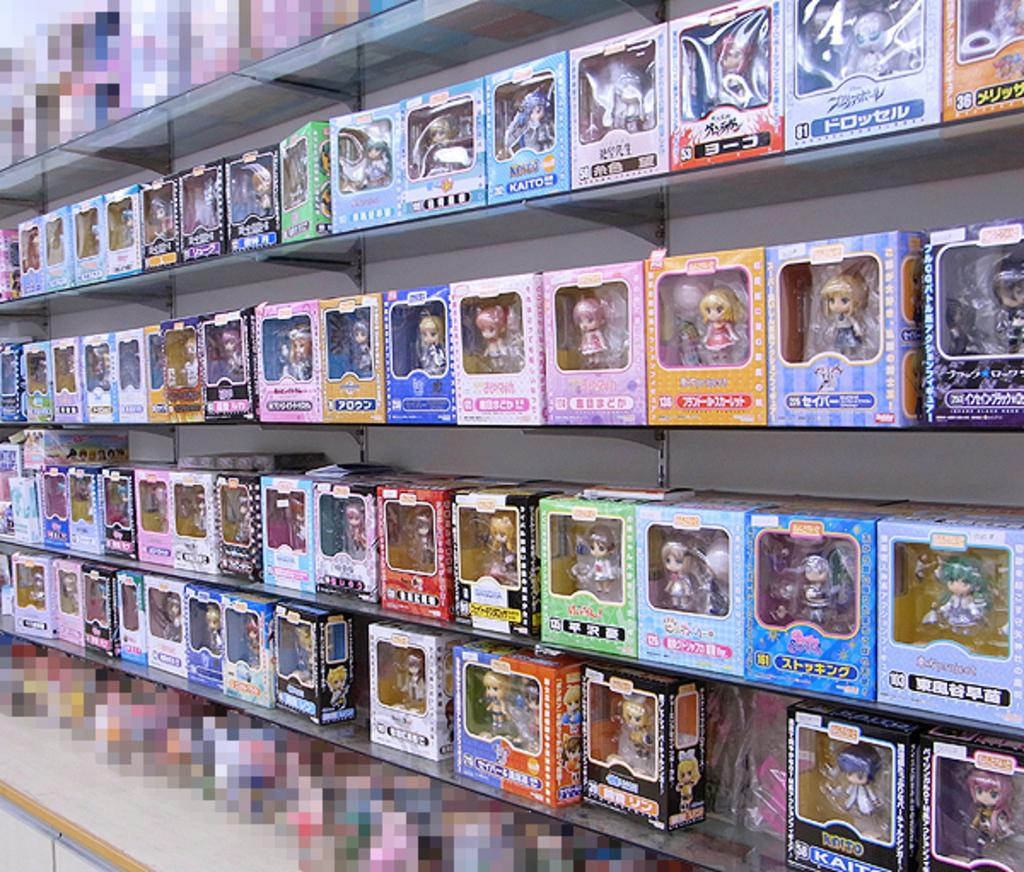<image>
Provide a brief description of the given image. One of many boxes on the shelves has the word "Kaito" on it. 